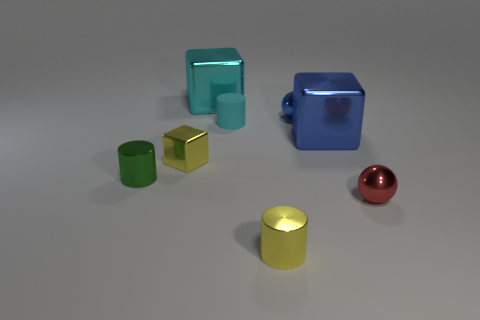What number of objects are either cyan objects or large cubes?
Your answer should be compact. 3. There is a tiny blue object that is behind the object that is to the left of the yellow metal cube; what shape is it?
Your answer should be compact. Sphere. What number of other objects are there of the same material as the tiny cyan cylinder?
Make the answer very short. 0. Is the material of the small cyan cylinder the same as the tiny sphere behind the tiny cyan thing?
Give a very brief answer. No. What number of objects are small metallic spheres that are in front of the cyan rubber thing or yellow shiny things right of the yellow cube?
Give a very brief answer. 2. What number of other things are the same color as the tiny rubber thing?
Provide a short and direct response. 1. Is the number of large objects left of the yellow metal cylinder greater than the number of big metallic blocks that are on the right side of the small cyan rubber cylinder?
Make the answer very short. No. Is there anything else that is the same size as the red sphere?
Offer a very short reply. Yes. What number of balls are tiny red metallic things or tiny things?
Your answer should be very brief. 2. How many objects are cyan things in front of the cyan metallic thing or small green things?
Your answer should be very brief. 2. 